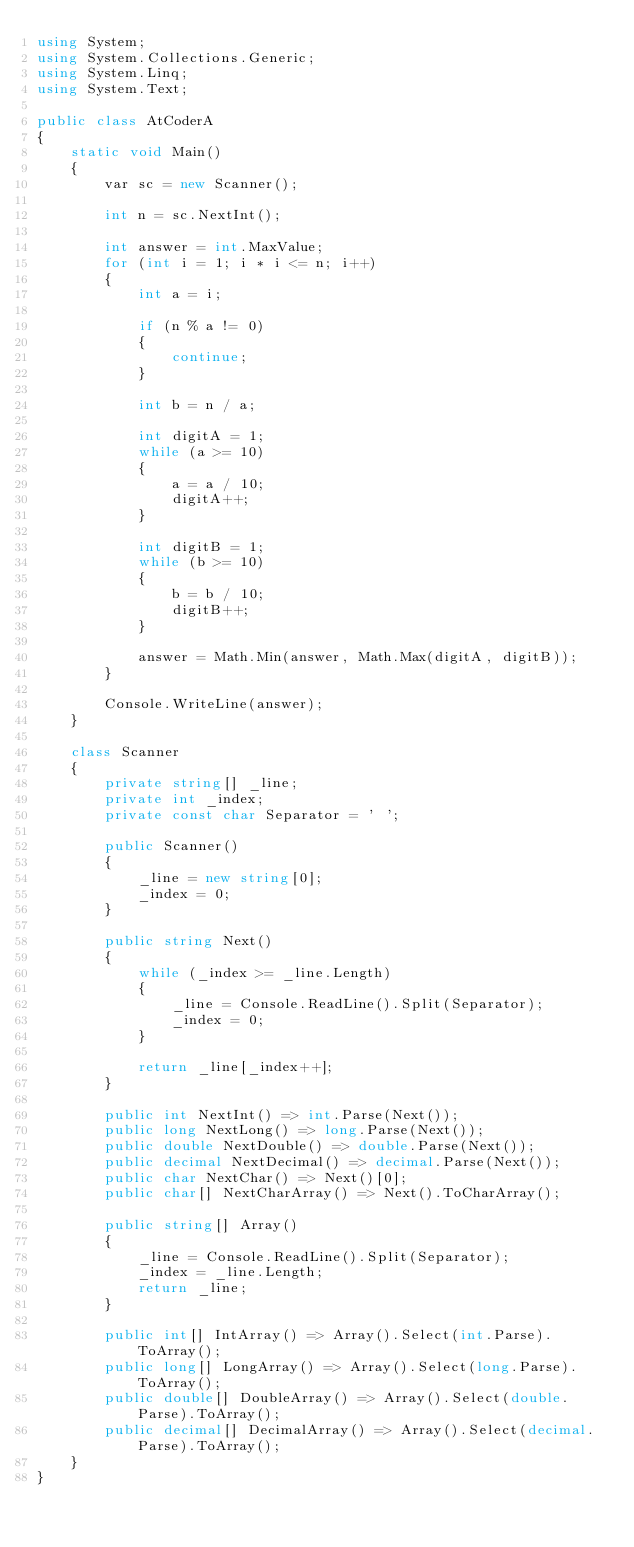<code> <loc_0><loc_0><loc_500><loc_500><_C#_>using System;
using System.Collections.Generic;
using System.Linq;
using System.Text;

public class AtCoderA
{
    static void Main()
    {
        var sc = new Scanner();

        int n = sc.NextInt();

        int answer = int.MaxValue;
        for (int i = 1; i * i <= n; i++)
        {
            int a = i;

            if (n % a != 0)
            {
                continue;
            }

            int b = n / a;

            int digitA = 1;
            while (a >= 10)
            {
                a = a / 10;
                digitA++;
            }

            int digitB = 1;
            while (b >= 10)
            {
                b = b / 10;
                digitB++;
            }

            answer = Math.Min(answer, Math.Max(digitA, digitB));
        }

        Console.WriteLine(answer);
    }

    class Scanner
    {
        private string[] _line;
        private int _index;
        private const char Separator = ' ';

        public Scanner()
        {
            _line = new string[0];
            _index = 0;
        }

        public string Next()
        {
            while (_index >= _line.Length)
            {
                _line = Console.ReadLine().Split(Separator);
                _index = 0;
            }

            return _line[_index++];
        }

        public int NextInt() => int.Parse(Next());
        public long NextLong() => long.Parse(Next());
        public double NextDouble() => double.Parse(Next());
        public decimal NextDecimal() => decimal.Parse(Next());
        public char NextChar() => Next()[0];
        public char[] NextCharArray() => Next().ToCharArray();

        public string[] Array()
        {
            _line = Console.ReadLine().Split(Separator);
            _index = _line.Length;
            return _line;
        }

        public int[] IntArray() => Array().Select(int.Parse).ToArray();
        public long[] LongArray() => Array().Select(long.Parse).ToArray();
        public double[] DoubleArray() => Array().Select(double.Parse).ToArray();
        public decimal[] DecimalArray() => Array().Select(decimal.Parse).ToArray();
    }
}</code> 